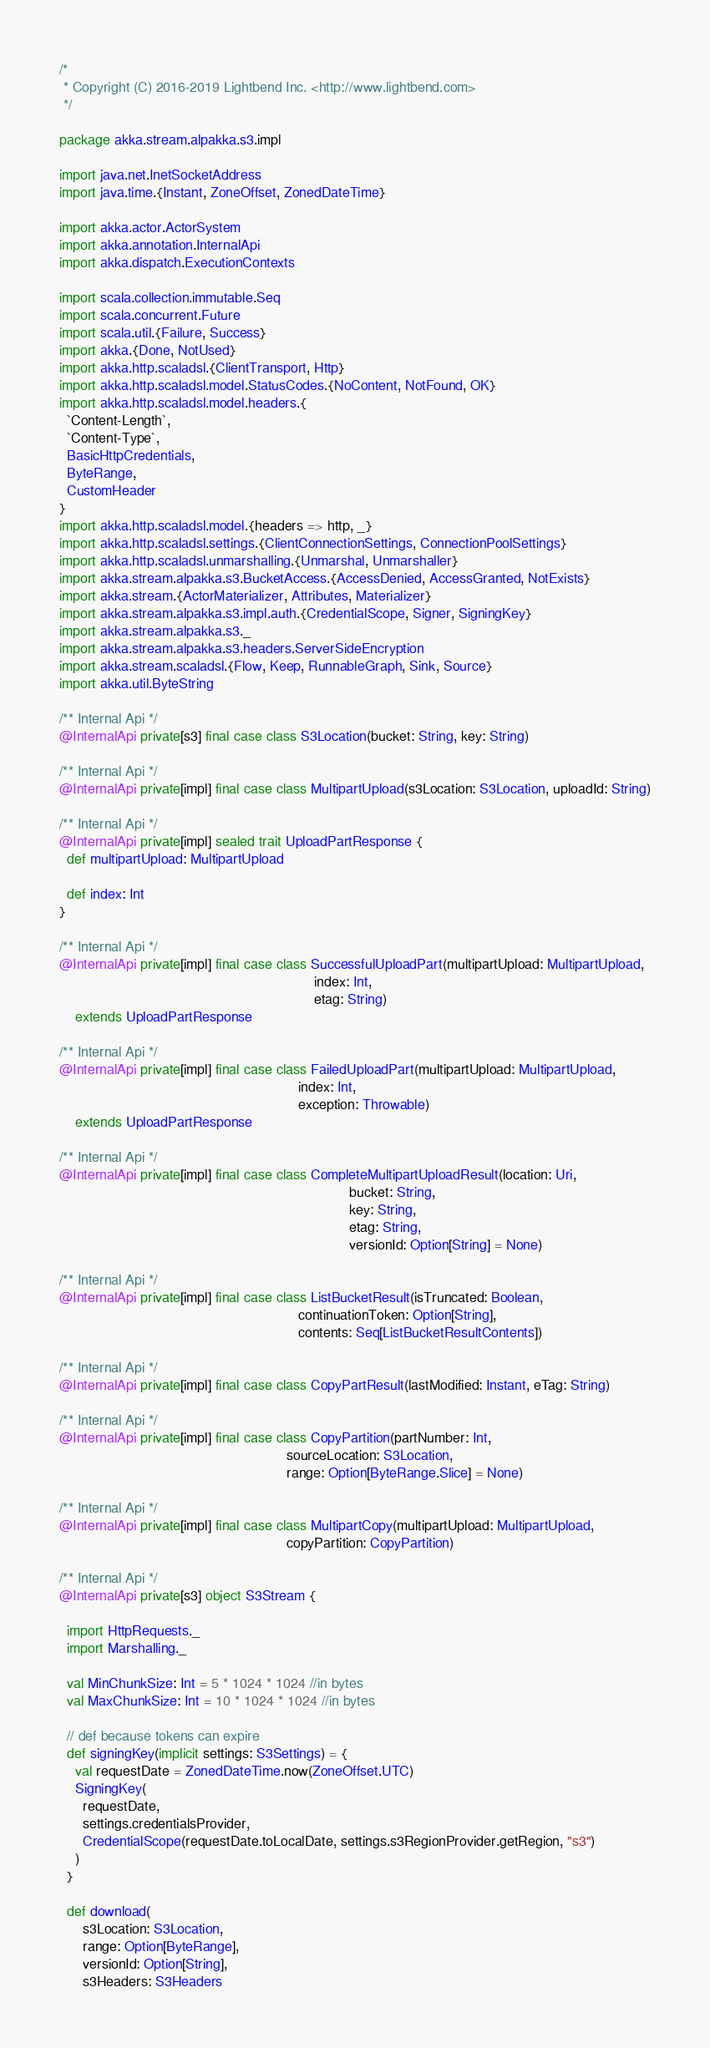<code> <loc_0><loc_0><loc_500><loc_500><_Scala_>/*
 * Copyright (C) 2016-2019 Lightbend Inc. <http://www.lightbend.com>
 */

package akka.stream.alpakka.s3.impl

import java.net.InetSocketAddress
import java.time.{Instant, ZoneOffset, ZonedDateTime}

import akka.actor.ActorSystem
import akka.annotation.InternalApi
import akka.dispatch.ExecutionContexts

import scala.collection.immutable.Seq
import scala.concurrent.Future
import scala.util.{Failure, Success}
import akka.{Done, NotUsed}
import akka.http.scaladsl.{ClientTransport, Http}
import akka.http.scaladsl.model.StatusCodes.{NoContent, NotFound, OK}
import akka.http.scaladsl.model.headers.{
  `Content-Length`,
  `Content-Type`,
  BasicHttpCredentials,
  ByteRange,
  CustomHeader
}
import akka.http.scaladsl.model.{headers => http, _}
import akka.http.scaladsl.settings.{ClientConnectionSettings, ConnectionPoolSettings}
import akka.http.scaladsl.unmarshalling.{Unmarshal, Unmarshaller}
import akka.stream.alpakka.s3.BucketAccess.{AccessDenied, AccessGranted, NotExists}
import akka.stream.{ActorMaterializer, Attributes, Materializer}
import akka.stream.alpakka.s3.impl.auth.{CredentialScope, Signer, SigningKey}
import akka.stream.alpakka.s3._
import akka.stream.alpakka.s3.headers.ServerSideEncryption
import akka.stream.scaladsl.{Flow, Keep, RunnableGraph, Sink, Source}
import akka.util.ByteString

/** Internal Api */
@InternalApi private[s3] final case class S3Location(bucket: String, key: String)

/** Internal Api */
@InternalApi private[impl] final case class MultipartUpload(s3Location: S3Location, uploadId: String)

/** Internal Api */
@InternalApi private[impl] sealed trait UploadPartResponse {
  def multipartUpload: MultipartUpload

  def index: Int
}

/** Internal Api */
@InternalApi private[impl] final case class SuccessfulUploadPart(multipartUpload: MultipartUpload,
                                                                 index: Int,
                                                                 etag: String)
    extends UploadPartResponse

/** Internal Api */
@InternalApi private[impl] final case class FailedUploadPart(multipartUpload: MultipartUpload,
                                                             index: Int,
                                                             exception: Throwable)
    extends UploadPartResponse

/** Internal Api */
@InternalApi private[impl] final case class CompleteMultipartUploadResult(location: Uri,
                                                                          bucket: String,
                                                                          key: String,
                                                                          etag: String,
                                                                          versionId: Option[String] = None)

/** Internal Api */
@InternalApi private[impl] final case class ListBucketResult(isTruncated: Boolean,
                                                             continuationToken: Option[String],
                                                             contents: Seq[ListBucketResultContents])

/** Internal Api */
@InternalApi private[impl] final case class CopyPartResult(lastModified: Instant, eTag: String)

/** Internal Api */
@InternalApi private[impl] final case class CopyPartition(partNumber: Int,
                                                          sourceLocation: S3Location,
                                                          range: Option[ByteRange.Slice] = None)

/** Internal Api */
@InternalApi private[impl] final case class MultipartCopy(multipartUpload: MultipartUpload,
                                                          copyPartition: CopyPartition)

/** Internal Api */
@InternalApi private[s3] object S3Stream {

  import HttpRequests._
  import Marshalling._

  val MinChunkSize: Int = 5 * 1024 * 1024 //in bytes
  val MaxChunkSize: Int = 10 * 1024 * 1024 //in bytes

  // def because tokens can expire
  def signingKey(implicit settings: S3Settings) = {
    val requestDate = ZonedDateTime.now(ZoneOffset.UTC)
    SigningKey(
      requestDate,
      settings.credentialsProvider,
      CredentialScope(requestDate.toLocalDate, settings.s3RegionProvider.getRegion, "s3")
    )
  }

  def download(
      s3Location: S3Location,
      range: Option[ByteRange],
      versionId: Option[String],
      s3Headers: S3Headers</code> 